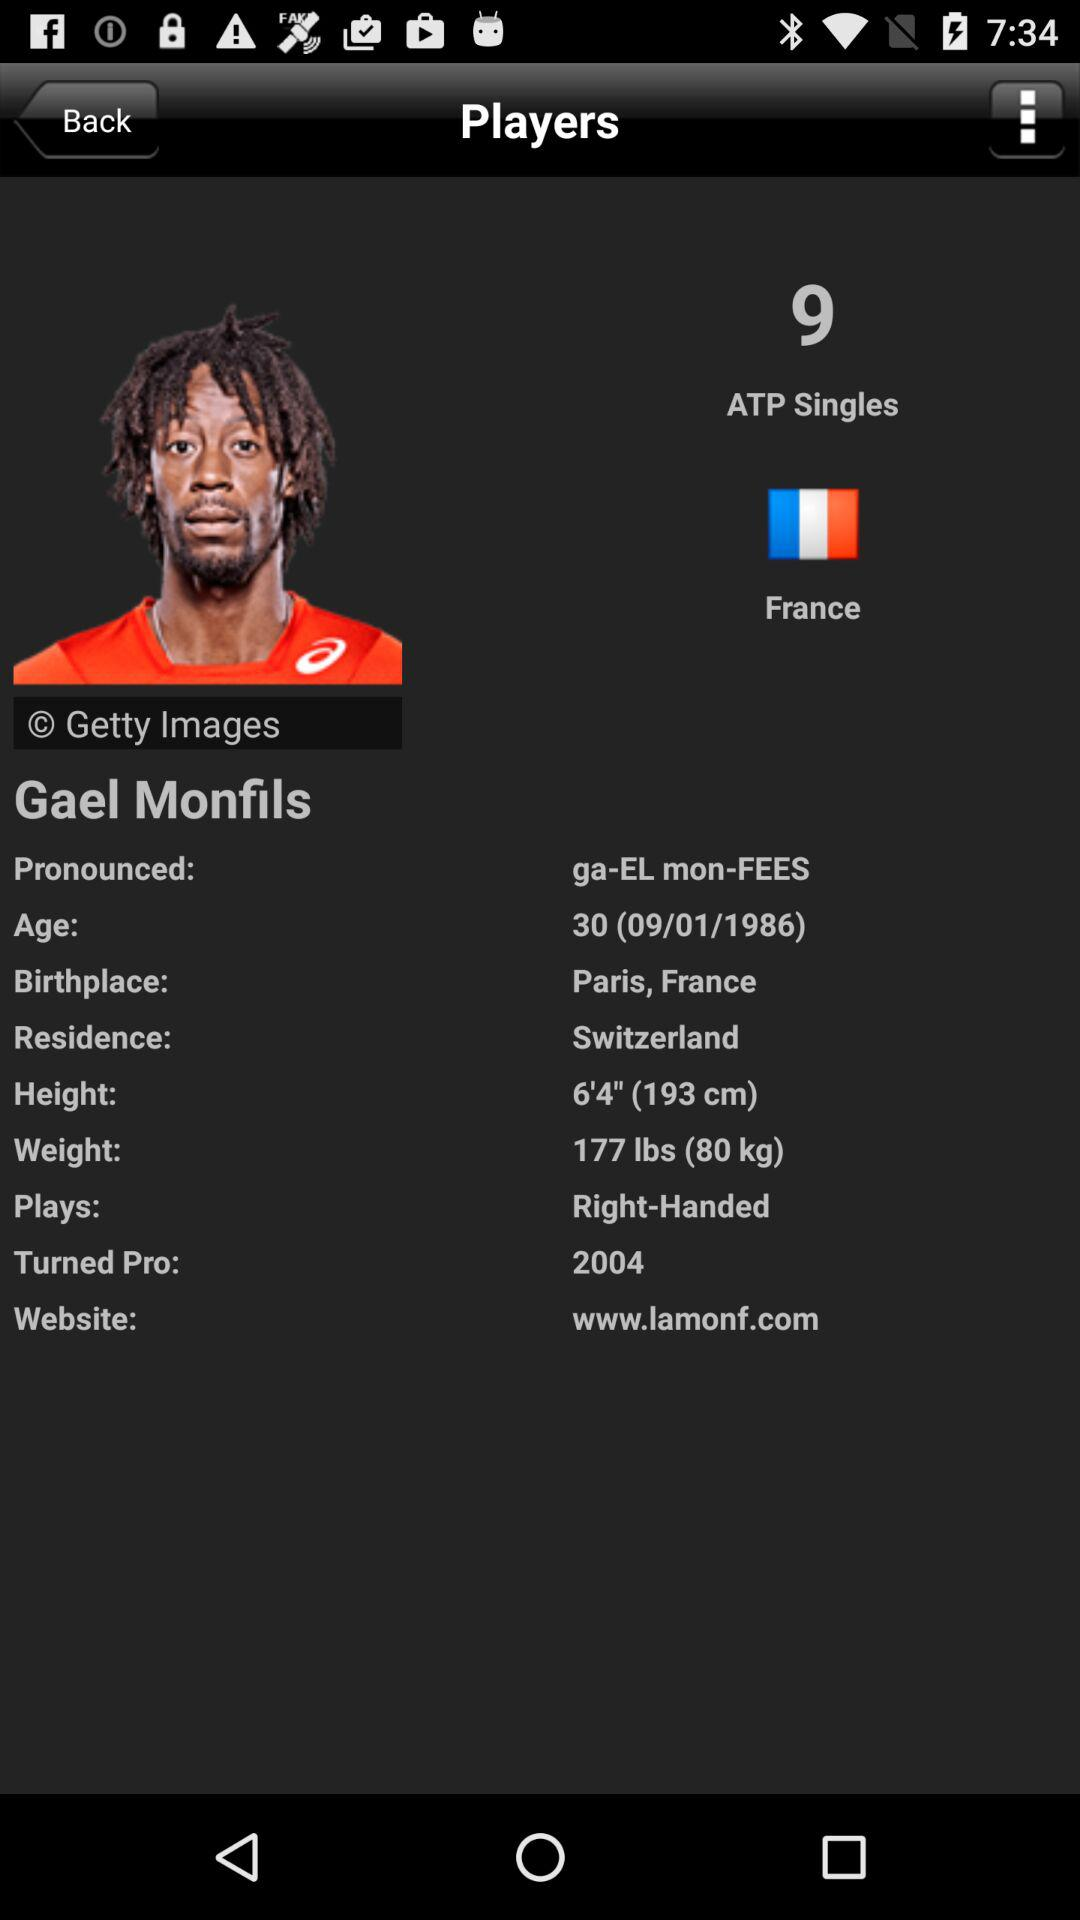Is Gael Monfils Right- Handed player?
When the provided information is insufficient, respond with <no answer>. <no answer> 